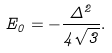<formula> <loc_0><loc_0><loc_500><loc_500>E _ { 0 } = - \frac { \Delta ^ { 2 } } { 4 \sqrt { 3 } } .</formula> 